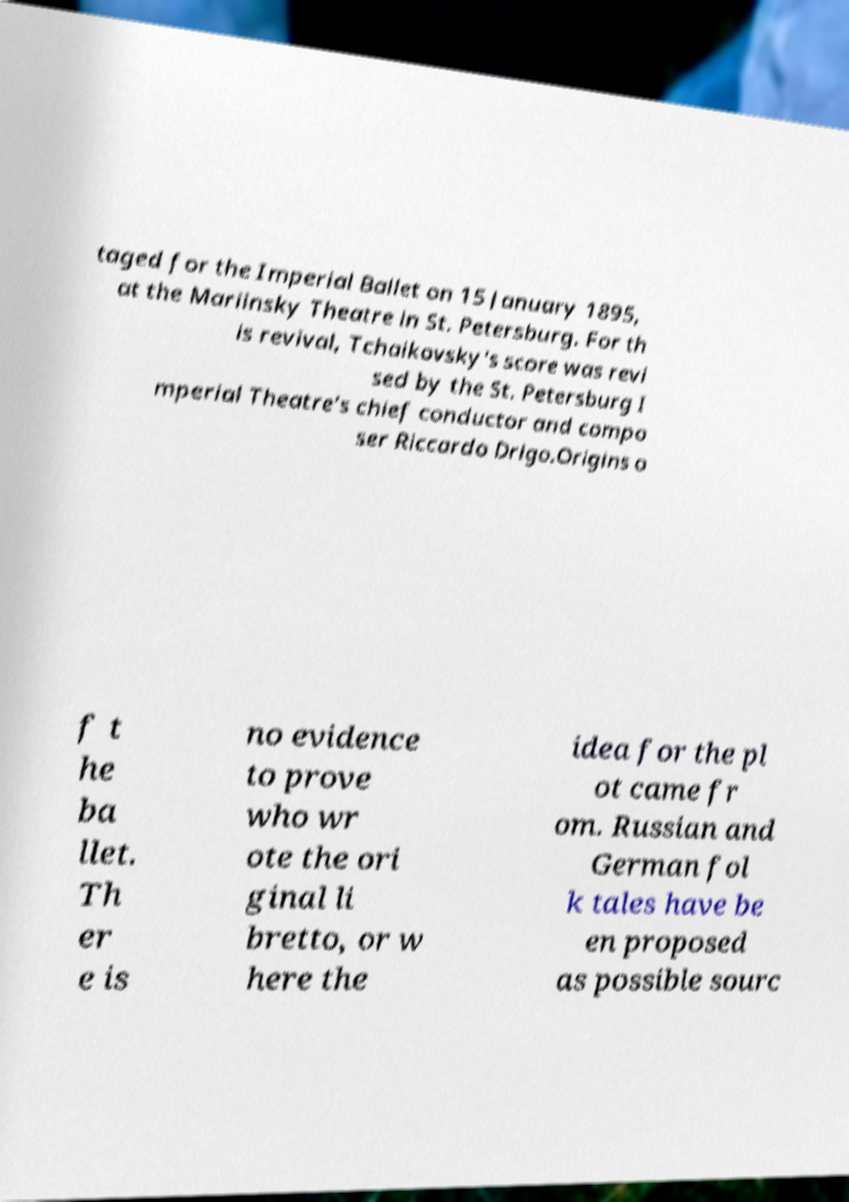Can you read and provide the text displayed in the image?This photo seems to have some interesting text. Can you extract and type it out for me? taged for the Imperial Ballet on 15 January 1895, at the Mariinsky Theatre in St. Petersburg. For th is revival, Tchaikovsky's score was revi sed by the St. Petersburg I mperial Theatre's chief conductor and compo ser Riccardo Drigo.Origins o f t he ba llet. Th er e is no evidence to prove who wr ote the ori ginal li bretto, or w here the idea for the pl ot came fr om. Russian and German fol k tales have be en proposed as possible sourc 